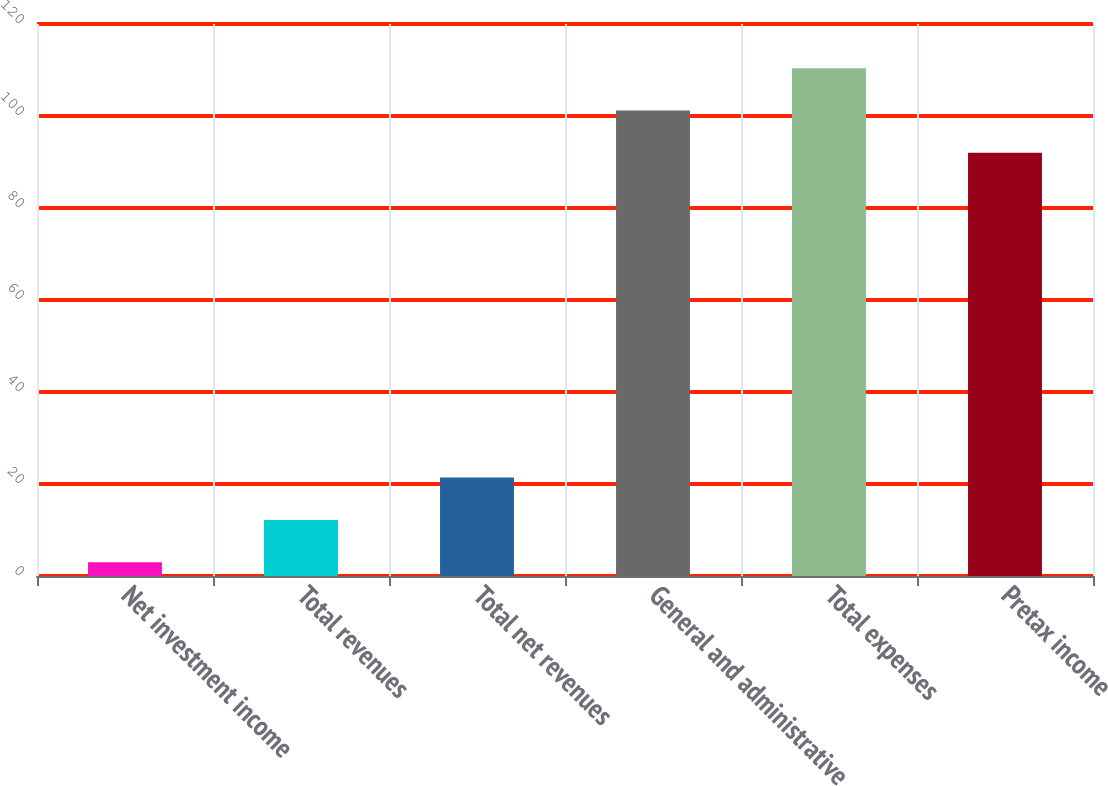Convert chart. <chart><loc_0><loc_0><loc_500><loc_500><bar_chart><fcel>Net investment income<fcel>Total revenues<fcel>Total net revenues<fcel>General and administrative<fcel>Total expenses<fcel>Pretax income<nl><fcel>3<fcel>12.2<fcel>21.4<fcel>101.2<fcel>110.4<fcel>92<nl></chart> 